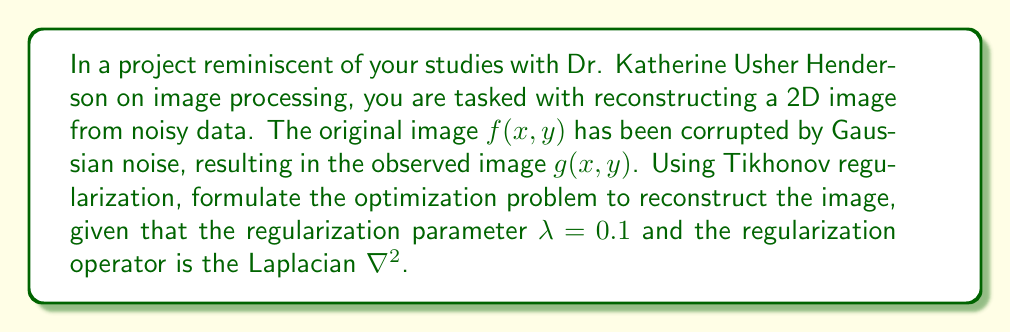Can you answer this question? Let's approach this step-by-step:

1) The general form of Tikhonov regularization for image reconstruction is:

   $$\min_f \{ \|Af - g\|^2 + \lambda \|Lf\|^2 \}$$

   where $A$ is the forward operator, $f$ is the image to be reconstructed, $g$ is the observed noisy image, $\lambda$ is the regularization parameter, and $L$ is the regularization operator.

2) In this case, we're dealing with direct observation of a noisy image, so $A$ is the identity operator.

3) The regularization operator is given as the Laplacian $\nabla^2$, which in 2D is:

   $$\nabla^2 f = \frac{\partial^2 f}{\partial x^2} + \frac{\partial^2 f}{\partial y^2}$$

4) The regularization parameter $\lambda$ is given as 0.1.

5) Substituting these into the general form, we get:

   $$\min_f \{ \|f - g\|^2 + 0.1 \|\nabla^2 f\|^2 \}$$

6) Expanding this, we have:

   $$\min_f \left\{ \int\int (f(x,y) - g(x,y))^2 dxdy + 0.1 \int\int \left(\frac{\partial^2 f}{\partial x^2} + \frac{\partial^2 f}{\partial y^2}\right)^2 dxdy \right\}$$

This is the final form of the optimization problem for reconstructing the image using Tikhonov regularization with the given parameters.
Answer: $$\min_f \left\{ \int\int (f(x,y) - g(x,y))^2 dxdy + 0.1 \int\int \left(\frac{\partial^2 f}{\partial x^2} + \frac{\partial^2 f}{\partial y^2}\right)^2 dxdy \right\}$$ 